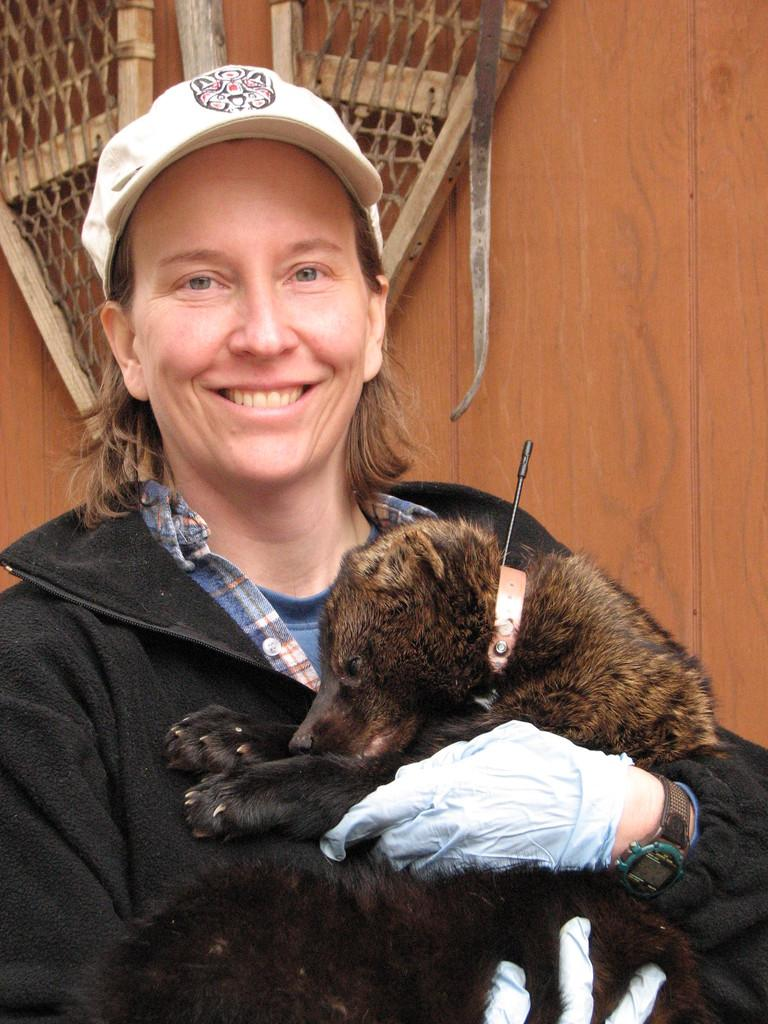Who is present in the image? There is a woman in the image. What is the woman wearing on her upper body? The woman is wearing a black jacket. What type of headwear is the woman wearing? The woman is wearing a cap. What is the woman holding in the image? The woman is holding a bear. What can be seen in the background of the image? There is a wooden object and a wall in the background of the image. What type of quill is the woman using to write on the metal surface in the image? There is no quill or metal surface present in the image; the woman is holding a bear and there is a wooden object and a wall in the background. 